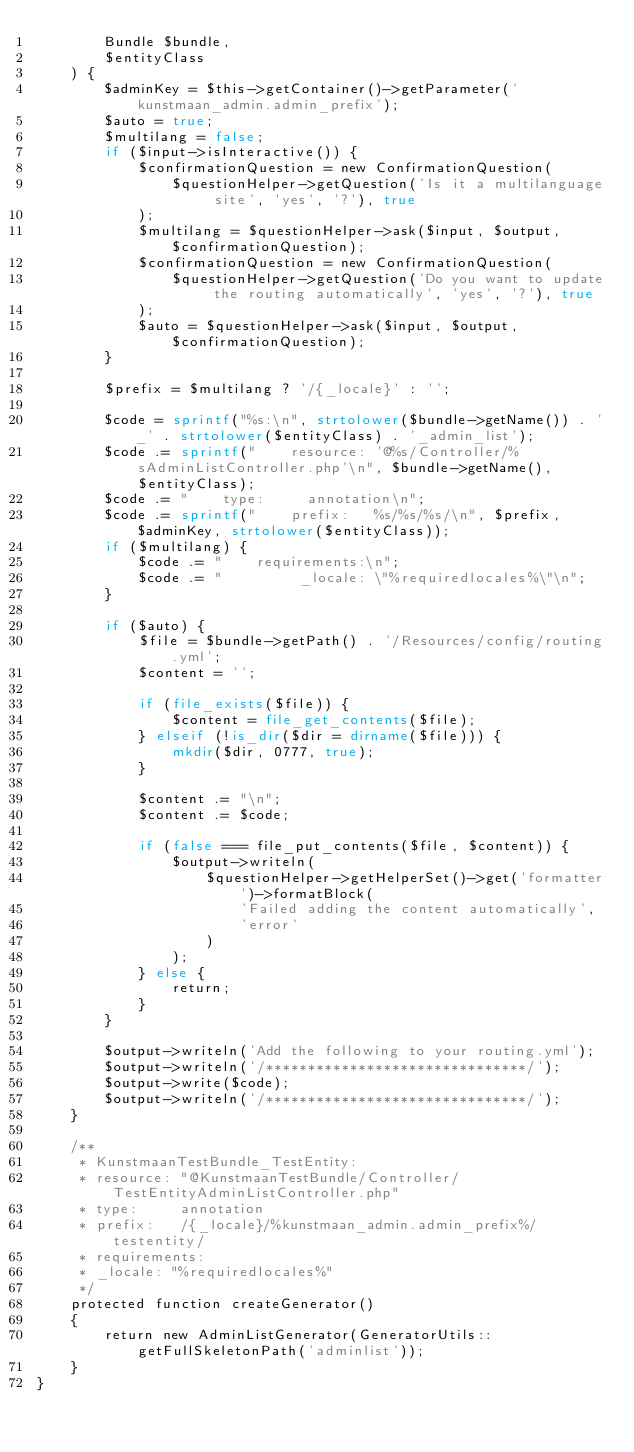Convert code to text. <code><loc_0><loc_0><loc_500><loc_500><_PHP_>        Bundle $bundle,
        $entityClass
    ) {
        $adminKey = $this->getContainer()->getParameter('kunstmaan_admin.admin_prefix');
        $auto = true;
        $multilang = false;
        if ($input->isInteractive()) {
            $confirmationQuestion = new ConfirmationQuestion(
                $questionHelper->getQuestion('Is it a multilanguage site', 'yes', '?'), true
            );
            $multilang = $questionHelper->ask($input, $output, $confirmationQuestion);
            $confirmationQuestion = new ConfirmationQuestion(
                $questionHelper->getQuestion('Do you want to update the routing automatically', 'yes', '?'), true
            );
            $auto = $questionHelper->ask($input, $output, $confirmationQuestion);
        }

        $prefix = $multilang ? '/{_locale}' : '';

        $code = sprintf("%s:\n", strtolower($bundle->getName()) . '_' . strtolower($entityClass) . '_admin_list');
        $code .= sprintf("    resource: '@%s/Controller/%sAdminListController.php'\n", $bundle->getName(), $entityClass);
        $code .= "    type:     annotation\n";
        $code .= sprintf("    prefix:   %s/%s/%s/\n", $prefix, $adminKey, strtolower($entityClass));
        if ($multilang) {
            $code .= "    requirements:\n";
            $code .= "         _locale: \"%requiredlocales%\"\n";
        }

        if ($auto) {
            $file = $bundle->getPath() . '/Resources/config/routing.yml';
            $content = '';

            if (file_exists($file)) {
                $content = file_get_contents($file);
            } elseif (!is_dir($dir = dirname($file))) {
                mkdir($dir, 0777, true);
            }

            $content .= "\n";
            $content .= $code;

            if (false === file_put_contents($file, $content)) {
                $output->writeln(
                    $questionHelper->getHelperSet()->get('formatter')->formatBlock(
                        'Failed adding the content automatically',
                        'error'
                    )
                );
            } else {
                return;
            }
        }

        $output->writeln('Add the following to your routing.yml');
        $output->writeln('/*******************************/');
        $output->write($code);
        $output->writeln('/*******************************/');
    }

    /**
     * KunstmaanTestBundle_TestEntity:
     * resource: "@KunstmaanTestBundle/Controller/TestEntityAdminListController.php"
     * type:     annotation
     * prefix:   /{_locale}/%kunstmaan_admin.admin_prefix%/testentity/
     * requirements:
     * _locale: "%requiredlocales%"
     */
    protected function createGenerator()
    {
        return new AdminListGenerator(GeneratorUtils::getFullSkeletonPath('adminlist'));
    }
}
</code> 